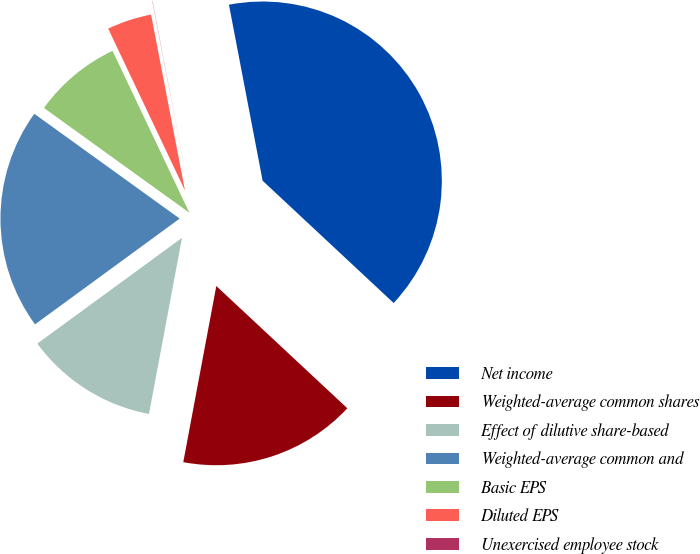<chart> <loc_0><loc_0><loc_500><loc_500><pie_chart><fcel>Net income<fcel>Weighted-average common shares<fcel>Effect of dilutive share-based<fcel>Weighted-average common and<fcel>Basic EPS<fcel>Diluted EPS<fcel>Unexercised employee stock<nl><fcel>39.96%<fcel>16.0%<fcel>12.0%<fcel>19.99%<fcel>8.01%<fcel>4.02%<fcel>0.02%<nl></chart> 